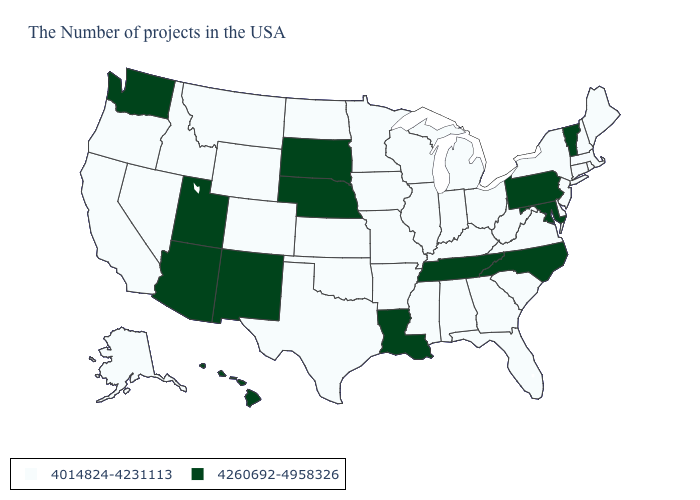Which states have the lowest value in the USA?
Give a very brief answer. Maine, Massachusetts, Rhode Island, New Hampshire, Connecticut, New York, New Jersey, Delaware, Virginia, South Carolina, West Virginia, Ohio, Florida, Georgia, Michigan, Kentucky, Indiana, Alabama, Wisconsin, Illinois, Mississippi, Missouri, Arkansas, Minnesota, Iowa, Kansas, Oklahoma, Texas, North Dakota, Wyoming, Colorado, Montana, Idaho, Nevada, California, Oregon, Alaska. Does Wyoming have the lowest value in the West?
Keep it brief. Yes. Name the states that have a value in the range 4014824-4231113?
Concise answer only. Maine, Massachusetts, Rhode Island, New Hampshire, Connecticut, New York, New Jersey, Delaware, Virginia, South Carolina, West Virginia, Ohio, Florida, Georgia, Michigan, Kentucky, Indiana, Alabama, Wisconsin, Illinois, Mississippi, Missouri, Arkansas, Minnesota, Iowa, Kansas, Oklahoma, Texas, North Dakota, Wyoming, Colorado, Montana, Idaho, Nevada, California, Oregon, Alaska. Name the states that have a value in the range 4260692-4958326?
Short answer required. Vermont, Maryland, Pennsylvania, North Carolina, Tennessee, Louisiana, Nebraska, South Dakota, New Mexico, Utah, Arizona, Washington, Hawaii. Does Tennessee have the highest value in the South?
Quick response, please. Yes. Name the states that have a value in the range 4014824-4231113?
Write a very short answer. Maine, Massachusetts, Rhode Island, New Hampshire, Connecticut, New York, New Jersey, Delaware, Virginia, South Carolina, West Virginia, Ohio, Florida, Georgia, Michigan, Kentucky, Indiana, Alabama, Wisconsin, Illinois, Mississippi, Missouri, Arkansas, Minnesota, Iowa, Kansas, Oklahoma, Texas, North Dakota, Wyoming, Colorado, Montana, Idaho, Nevada, California, Oregon, Alaska. Name the states that have a value in the range 4014824-4231113?
Keep it brief. Maine, Massachusetts, Rhode Island, New Hampshire, Connecticut, New York, New Jersey, Delaware, Virginia, South Carolina, West Virginia, Ohio, Florida, Georgia, Michigan, Kentucky, Indiana, Alabama, Wisconsin, Illinois, Mississippi, Missouri, Arkansas, Minnesota, Iowa, Kansas, Oklahoma, Texas, North Dakota, Wyoming, Colorado, Montana, Idaho, Nevada, California, Oregon, Alaska. What is the value of Arizona?
Quick response, please. 4260692-4958326. What is the lowest value in the MidWest?
Concise answer only. 4014824-4231113. Among the states that border Arkansas , which have the lowest value?
Give a very brief answer. Mississippi, Missouri, Oklahoma, Texas. Name the states that have a value in the range 4260692-4958326?
Give a very brief answer. Vermont, Maryland, Pennsylvania, North Carolina, Tennessee, Louisiana, Nebraska, South Dakota, New Mexico, Utah, Arizona, Washington, Hawaii. Does the map have missing data?
Write a very short answer. No. Does the first symbol in the legend represent the smallest category?
Concise answer only. Yes. What is the value of North Carolina?
Keep it brief. 4260692-4958326. What is the highest value in states that border Texas?
Short answer required. 4260692-4958326. 